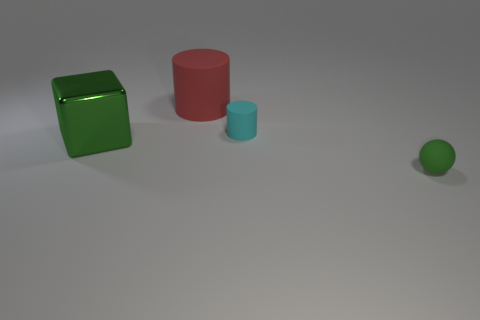Subtract all balls. How many objects are left? 3 Subtract 1 spheres. How many spheres are left? 0 Subtract all gray cylinders. Subtract all gray blocks. How many cylinders are left? 2 Subtract all blue cubes. How many red cylinders are left? 1 Subtract all big green things. Subtract all small cyan things. How many objects are left? 2 Add 2 green matte things. How many green matte things are left? 3 Add 3 cyan spheres. How many cyan spheres exist? 3 Add 2 cyan rubber cylinders. How many objects exist? 6 Subtract all cyan cylinders. How many cylinders are left? 1 Subtract 0 blue cylinders. How many objects are left? 4 